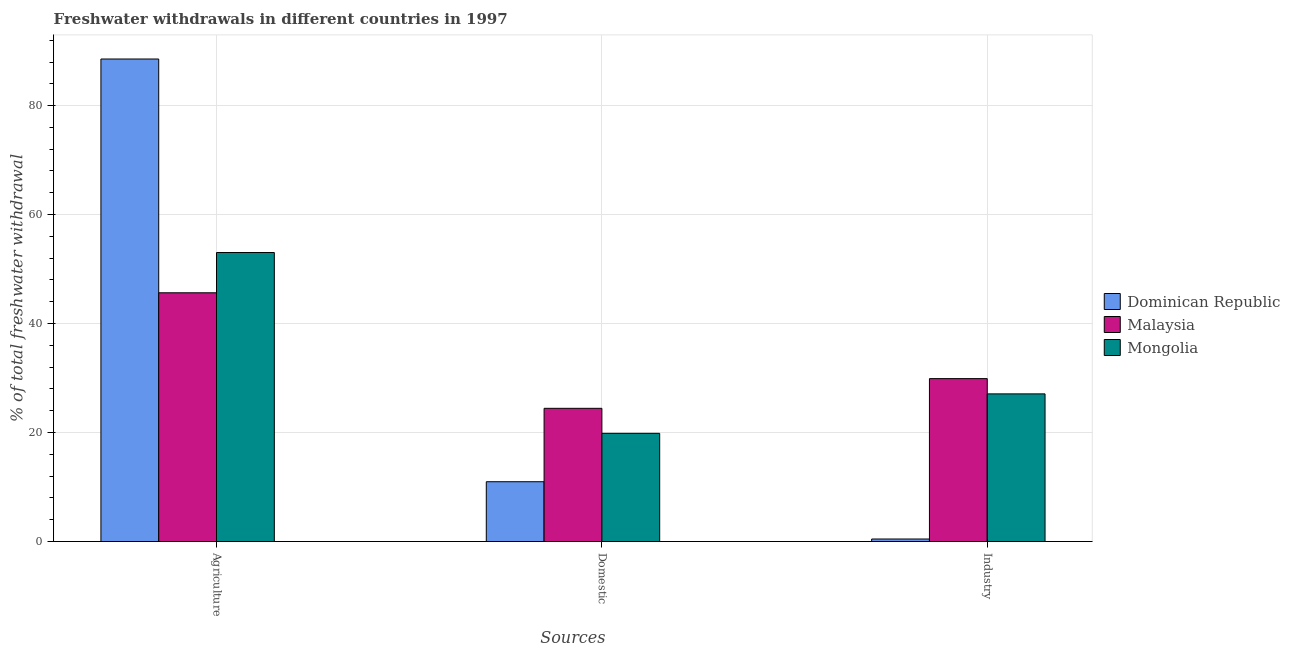How many different coloured bars are there?
Provide a short and direct response. 3. How many groups of bars are there?
Give a very brief answer. 3. Are the number of bars per tick equal to the number of legend labels?
Offer a very short reply. Yes. Are the number of bars on each tick of the X-axis equal?
Keep it short and to the point. Yes. How many bars are there on the 1st tick from the right?
Offer a very short reply. 3. What is the label of the 2nd group of bars from the left?
Make the answer very short. Domestic. What is the percentage of freshwater withdrawal for domestic purposes in Mongolia?
Your response must be concise. 19.86. Across all countries, what is the maximum percentage of freshwater withdrawal for domestic purposes?
Make the answer very short. 24.45. Across all countries, what is the minimum percentage of freshwater withdrawal for industry?
Provide a succinct answer. 0.47. In which country was the percentage of freshwater withdrawal for agriculture maximum?
Provide a succinct answer. Dominican Republic. In which country was the percentage of freshwater withdrawal for domestic purposes minimum?
Provide a succinct answer. Dominican Republic. What is the total percentage of freshwater withdrawal for domestic purposes in the graph?
Give a very brief answer. 55.29. What is the difference between the percentage of freshwater withdrawal for agriculture in Mongolia and that in Dominican Republic?
Your response must be concise. -35.51. What is the difference between the percentage of freshwater withdrawal for industry in Dominican Republic and the percentage of freshwater withdrawal for agriculture in Mongolia?
Your answer should be compact. -52.57. What is the average percentage of freshwater withdrawal for industry per country?
Your response must be concise. 19.16. What is the difference between the percentage of freshwater withdrawal for domestic purposes and percentage of freshwater withdrawal for industry in Malaysia?
Offer a very short reply. -5.45. In how many countries, is the percentage of freshwater withdrawal for domestic purposes greater than 60 %?
Provide a short and direct response. 0. What is the ratio of the percentage of freshwater withdrawal for domestic purposes in Malaysia to that in Dominican Republic?
Your answer should be compact. 2.23. What is the difference between the highest and the second highest percentage of freshwater withdrawal for industry?
Provide a succinct answer. 2.8. What is the difference between the highest and the lowest percentage of freshwater withdrawal for industry?
Provide a short and direct response. 29.43. In how many countries, is the percentage of freshwater withdrawal for agriculture greater than the average percentage of freshwater withdrawal for agriculture taken over all countries?
Offer a terse response. 1. What does the 2nd bar from the left in Agriculture represents?
Keep it short and to the point. Malaysia. What does the 2nd bar from the right in Agriculture represents?
Offer a terse response. Malaysia. Is it the case that in every country, the sum of the percentage of freshwater withdrawal for agriculture and percentage of freshwater withdrawal for domestic purposes is greater than the percentage of freshwater withdrawal for industry?
Provide a short and direct response. Yes. How many countries are there in the graph?
Provide a short and direct response. 3. What is the difference between two consecutive major ticks on the Y-axis?
Offer a terse response. 20. Does the graph contain any zero values?
Your answer should be very brief. No. How many legend labels are there?
Offer a terse response. 3. What is the title of the graph?
Provide a succinct answer. Freshwater withdrawals in different countries in 1997. What is the label or title of the X-axis?
Give a very brief answer. Sources. What is the label or title of the Y-axis?
Give a very brief answer. % of total freshwater withdrawal. What is the % of total freshwater withdrawal in Dominican Republic in Agriculture?
Ensure brevity in your answer.  88.55. What is the % of total freshwater withdrawal of Malaysia in Agriculture?
Provide a succinct answer. 45.65. What is the % of total freshwater withdrawal in Mongolia in Agriculture?
Your answer should be compact. 53.04. What is the % of total freshwater withdrawal of Dominican Republic in Domestic?
Offer a terse response. 10.98. What is the % of total freshwater withdrawal of Malaysia in Domestic?
Make the answer very short. 24.45. What is the % of total freshwater withdrawal in Mongolia in Domestic?
Your answer should be compact. 19.86. What is the % of total freshwater withdrawal of Dominican Republic in Industry?
Offer a terse response. 0.47. What is the % of total freshwater withdrawal in Malaysia in Industry?
Offer a terse response. 29.9. What is the % of total freshwater withdrawal in Mongolia in Industry?
Keep it short and to the point. 27.1. Across all Sources, what is the maximum % of total freshwater withdrawal in Dominican Republic?
Your response must be concise. 88.55. Across all Sources, what is the maximum % of total freshwater withdrawal in Malaysia?
Provide a succinct answer. 45.65. Across all Sources, what is the maximum % of total freshwater withdrawal of Mongolia?
Keep it short and to the point. 53.04. Across all Sources, what is the minimum % of total freshwater withdrawal of Dominican Republic?
Keep it short and to the point. 0.47. Across all Sources, what is the minimum % of total freshwater withdrawal in Malaysia?
Provide a short and direct response. 24.45. Across all Sources, what is the minimum % of total freshwater withdrawal in Mongolia?
Your answer should be very brief. 19.86. What is the total % of total freshwater withdrawal of Dominican Republic in the graph?
Offer a terse response. 100. What is the total % of total freshwater withdrawal in Malaysia in the graph?
Give a very brief answer. 100. What is the total % of total freshwater withdrawal in Mongolia in the graph?
Keep it short and to the point. 100. What is the difference between the % of total freshwater withdrawal in Dominican Republic in Agriculture and that in Domestic?
Keep it short and to the point. 77.57. What is the difference between the % of total freshwater withdrawal of Malaysia in Agriculture and that in Domestic?
Offer a very short reply. 21.2. What is the difference between the % of total freshwater withdrawal of Mongolia in Agriculture and that in Domestic?
Your answer should be compact. 33.18. What is the difference between the % of total freshwater withdrawal in Dominican Republic in Agriculture and that in Industry?
Your answer should be compact. 88.08. What is the difference between the % of total freshwater withdrawal in Malaysia in Agriculture and that in Industry?
Make the answer very short. 15.75. What is the difference between the % of total freshwater withdrawal in Mongolia in Agriculture and that in Industry?
Make the answer very short. 25.94. What is the difference between the % of total freshwater withdrawal in Dominican Republic in Domestic and that in Industry?
Your answer should be very brief. 10.51. What is the difference between the % of total freshwater withdrawal in Malaysia in Domestic and that in Industry?
Offer a very short reply. -5.45. What is the difference between the % of total freshwater withdrawal in Mongolia in Domestic and that in Industry?
Provide a succinct answer. -7.24. What is the difference between the % of total freshwater withdrawal in Dominican Republic in Agriculture and the % of total freshwater withdrawal in Malaysia in Domestic?
Provide a short and direct response. 64.1. What is the difference between the % of total freshwater withdrawal in Dominican Republic in Agriculture and the % of total freshwater withdrawal in Mongolia in Domestic?
Your answer should be very brief. 68.69. What is the difference between the % of total freshwater withdrawal of Malaysia in Agriculture and the % of total freshwater withdrawal of Mongolia in Domestic?
Your answer should be compact. 25.79. What is the difference between the % of total freshwater withdrawal of Dominican Republic in Agriculture and the % of total freshwater withdrawal of Malaysia in Industry?
Your answer should be compact. 58.65. What is the difference between the % of total freshwater withdrawal in Dominican Republic in Agriculture and the % of total freshwater withdrawal in Mongolia in Industry?
Give a very brief answer. 61.45. What is the difference between the % of total freshwater withdrawal of Malaysia in Agriculture and the % of total freshwater withdrawal of Mongolia in Industry?
Your answer should be very brief. 18.55. What is the difference between the % of total freshwater withdrawal of Dominican Republic in Domestic and the % of total freshwater withdrawal of Malaysia in Industry?
Provide a short and direct response. -18.92. What is the difference between the % of total freshwater withdrawal in Dominican Republic in Domestic and the % of total freshwater withdrawal in Mongolia in Industry?
Make the answer very short. -16.12. What is the difference between the % of total freshwater withdrawal in Malaysia in Domestic and the % of total freshwater withdrawal in Mongolia in Industry?
Your response must be concise. -2.65. What is the average % of total freshwater withdrawal in Dominican Republic per Sources?
Your answer should be very brief. 33.33. What is the average % of total freshwater withdrawal in Malaysia per Sources?
Your answer should be very brief. 33.33. What is the average % of total freshwater withdrawal in Mongolia per Sources?
Your response must be concise. 33.33. What is the difference between the % of total freshwater withdrawal of Dominican Republic and % of total freshwater withdrawal of Malaysia in Agriculture?
Keep it short and to the point. 42.9. What is the difference between the % of total freshwater withdrawal in Dominican Republic and % of total freshwater withdrawal in Mongolia in Agriculture?
Your answer should be very brief. 35.51. What is the difference between the % of total freshwater withdrawal in Malaysia and % of total freshwater withdrawal in Mongolia in Agriculture?
Keep it short and to the point. -7.39. What is the difference between the % of total freshwater withdrawal in Dominican Republic and % of total freshwater withdrawal in Malaysia in Domestic?
Ensure brevity in your answer.  -13.47. What is the difference between the % of total freshwater withdrawal of Dominican Republic and % of total freshwater withdrawal of Mongolia in Domestic?
Offer a very short reply. -8.88. What is the difference between the % of total freshwater withdrawal in Malaysia and % of total freshwater withdrawal in Mongolia in Domestic?
Your answer should be compact. 4.59. What is the difference between the % of total freshwater withdrawal in Dominican Republic and % of total freshwater withdrawal in Malaysia in Industry?
Give a very brief answer. -29.43. What is the difference between the % of total freshwater withdrawal in Dominican Republic and % of total freshwater withdrawal in Mongolia in Industry?
Keep it short and to the point. -26.63. What is the ratio of the % of total freshwater withdrawal of Dominican Republic in Agriculture to that in Domestic?
Give a very brief answer. 8.06. What is the ratio of the % of total freshwater withdrawal in Malaysia in Agriculture to that in Domestic?
Your response must be concise. 1.87. What is the ratio of the % of total freshwater withdrawal in Mongolia in Agriculture to that in Domestic?
Your answer should be very brief. 2.67. What is the ratio of the % of total freshwater withdrawal in Dominican Republic in Agriculture to that in Industry?
Provide a succinct answer. 189.33. What is the ratio of the % of total freshwater withdrawal in Malaysia in Agriculture to that in Industry?
Keep it short and to the point. 1.53. What is the ratio of the % of total freshwater withdrawal in Mongolia in Agriculture to that in Industry?
Provide a succinct answer. 1.96. What is the ratio of the % of total freshwater withdrawal in Dominican Republic in Domestic to that in Industry?
Offer a terse response. 23.48. What is the ratio of the % of total freshwater withdrawal in Malaysia in Domestic to that in Industry?
Keep it short and to the point. 0.82. What is the ratio of the % of total freshwater withdrawal in Mongolia in Domestic to that in Industry?
Offer a terse response. 0.73. What is the difference between the highest and the second highest % of total freshwater withdrawal in Dominican Republic?
Give a very brief answer. 77.57. What is the difference between the highest and the second highest % of total freshwater withdrawal in Malaysia?
Provide a short and direct response. 15.75. What is the difference between the highest and the second highest % of total freshwater withdrawal in Mongolia?
Give a very brief answer. 25.94. What is the difference between the highest and the lowest % of total freshwater withdrawal in Dominican Republic?
Your response must be concise. 88.08. What is the difference between the highest and the lowest % of total freshwater withdrawal of Malaysia?
Offer a very short reply. 21.2. What is the difference between the highest and the lowest % of total freshwater withdrawal in Mongolia?
Make the answer very short. 33.18. 